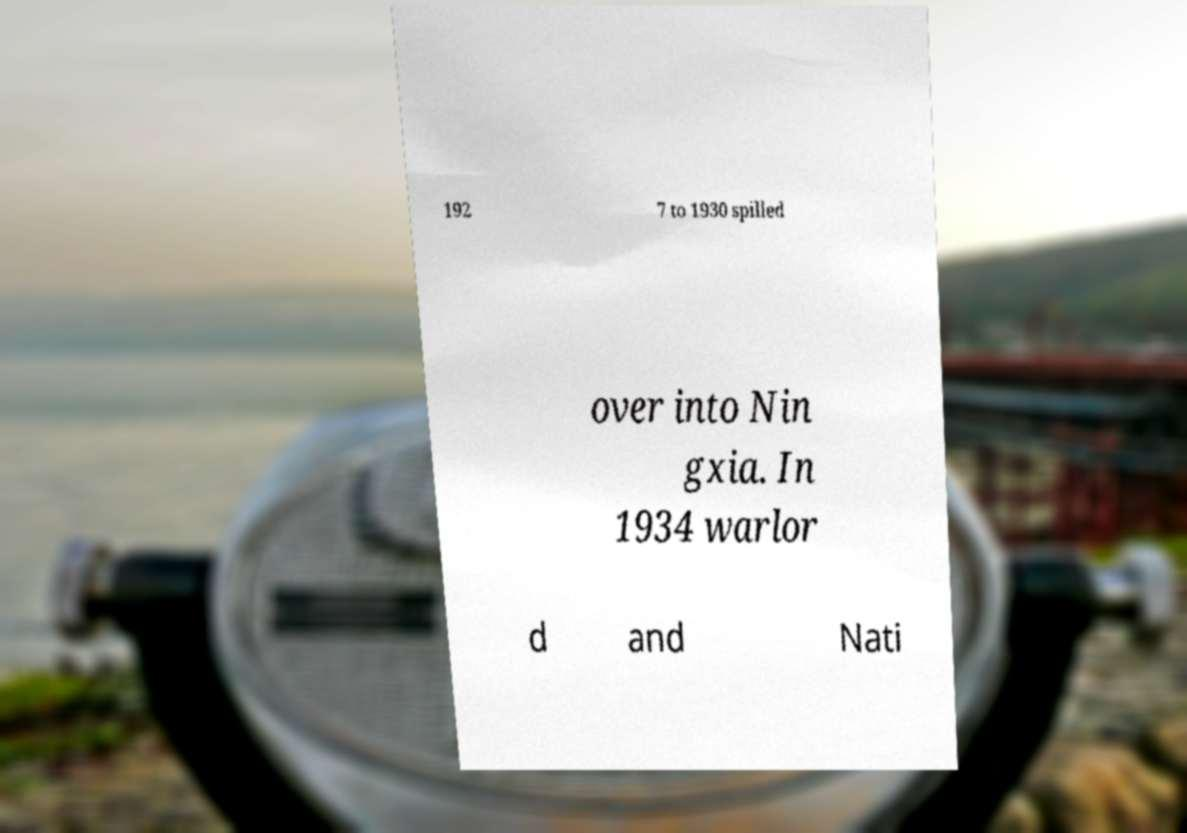Can you accurately transcribe the text from the provided image for me? 192 7 to 1930 spilled over into Nin gxia. In 1934 warlor d and Nati 